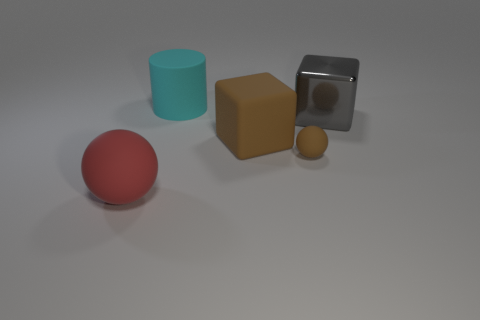Add 3 yellow things. How many objects exist? 8 Subtract all blocks. How many objects are left? 3 Subtract 0 green cylinders. How many objects are left? 5 Subtract all matte cylinders. Subtract all big matte cubes. How many objects are left? 3 Add 3 small brown balls. How many small brown balls are left? 4 Add 5 large green metal balls. How many large green metal balls exist? 5 